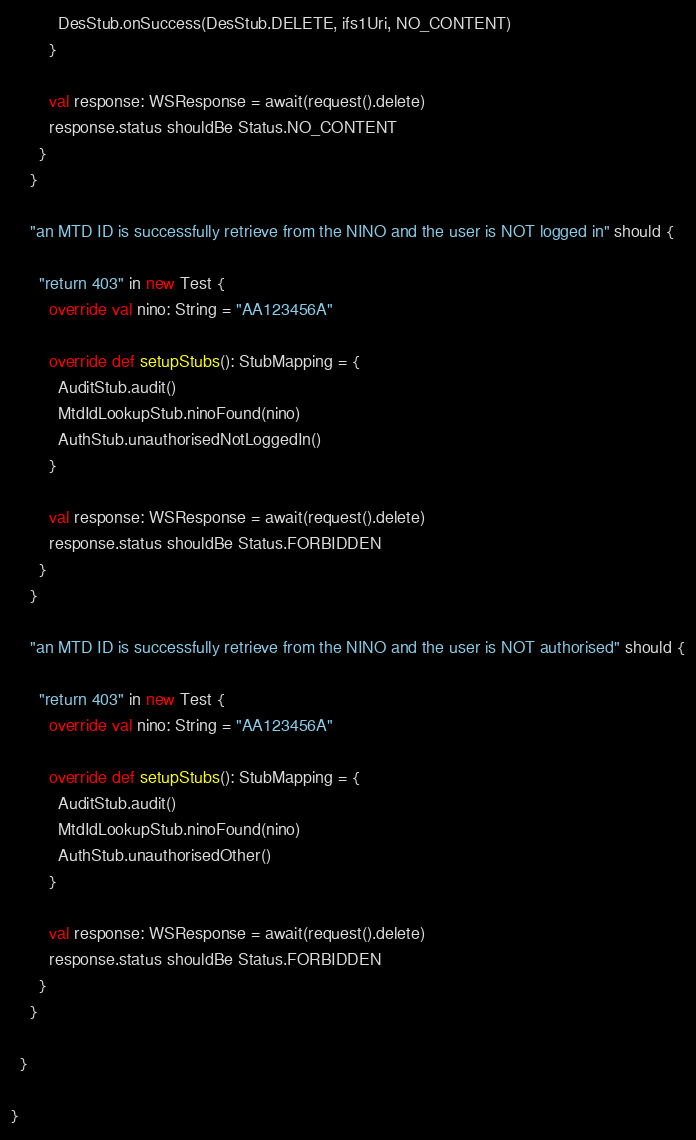<code> <loc_0><loc_0><loc_500><loc_500><_Scala_>          DesStub.onSuccess(DesStub.DELETE, ifs1Uri, NO_CONTENT)
        }

        val response: WSResponse = await(request().delete)
        response.status shouldBe Status.NO_CONTENT
      }
    }

    "an MTD ID is successfully retrieve from the NINO and the user is NOT logged in" should {

      "return 403" in new Test {
        override val nino: String = "AA123456A"

        override def setupStubs(): StubMapping = {
          AuditStub.audit()
          MtdIdLookupStub.ninoFound(nino)
          AuthStub.unauthorisedNotLoggedIn()
        }

        val response: WSResponse = await(request().delete)
        response.status shouldBe Status.FORBIDDEN
      }
    }

    "an MTD ID is successfully retrieve from the NINO and the user is NOT authorised" should {

      "return 403" in new Test {
        override val nino: String = "AA123456A"

        override def setupStubs(): StubMapping = {
          AuditStub.audit()
          MtdIdLookupStub.ninoFound(nino)
          AuthStub.unauthorisedOther()
        }

        val response: WSResponse = await(request().delete)
        response.status shouldBe Status.FORBIDDEN
      }
    }

  }

}</code> 